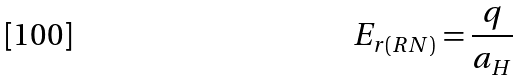Convert formula to latex. <formula><loc_0><loc_0><loc_500><loc_500>E _ { r ( R N ) } = \frac { q } { a _ { H } }</formula> 